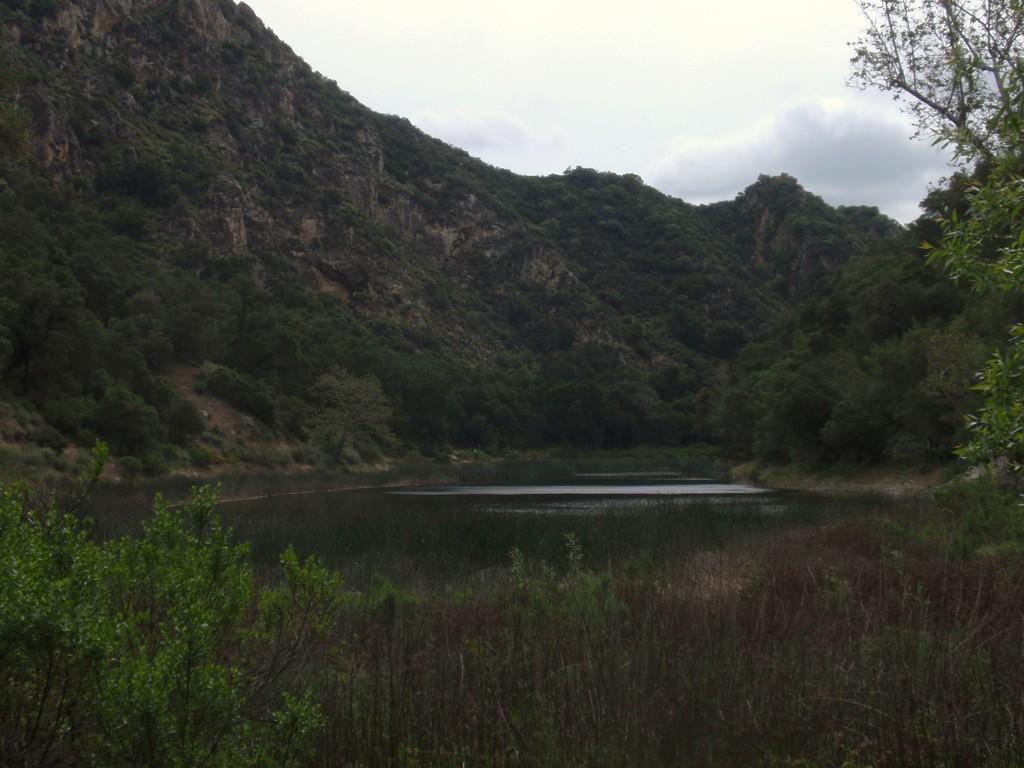Please provide a concise description of this image. In the foreground of this image, there is greenery. In the middle, there is water and we can also see greenery on the cliff. At the top, there is the sky. 